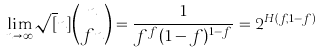Convert formula to latex. <formula><loc_0><loc_0><loc_500><loc_500>\lim _ { n \rightarrow \infty } \sqrt { [ } n ] { \binom { n } { f n } } = \frac { 1 } { f ^ { f } ( 1 - f ) ^ { 1 - f } } = 2 ^ { H ( f , 1 - f ) }</formula> 